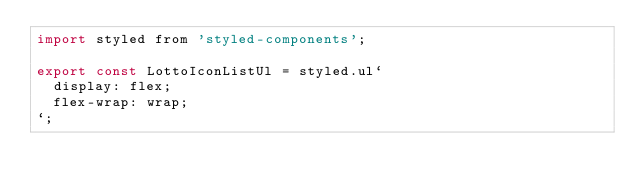<code> <loc_0><loc_0><loc_500><loc_500><_JavaScript_>import styled from 'styled-components';

export const LottoIconListUl = styled.ul`
  display: flex;
  flex-wrap: wrap;
`;
</code> 